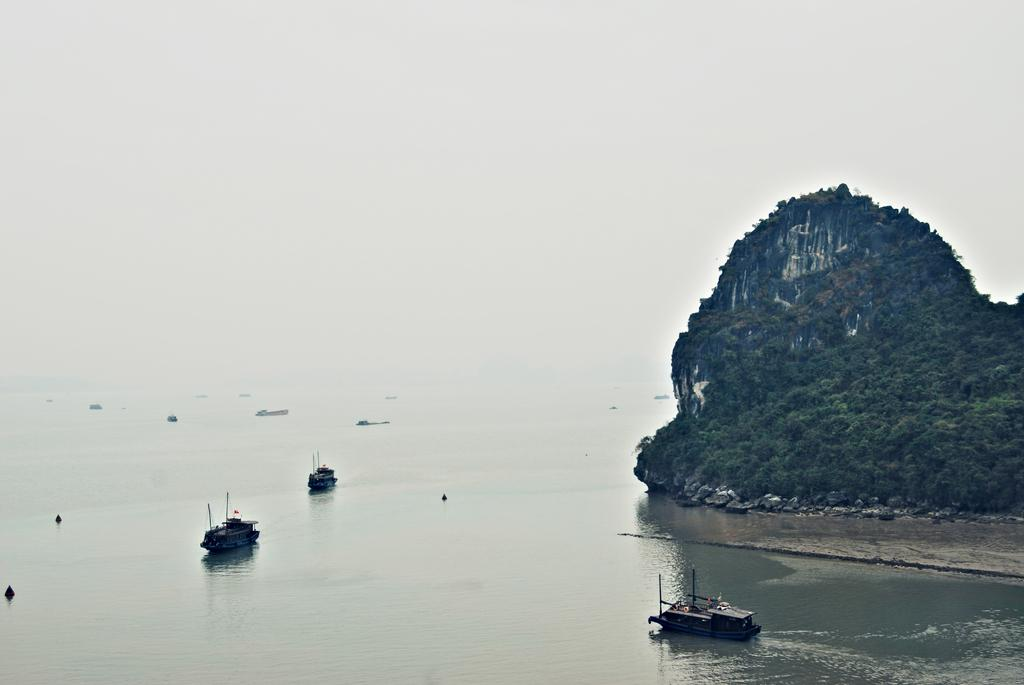What is in the water in the image? There are boats in the water in the image. What can be seen on the right side of the image? There are trees on the right side of the image. What is located behind the trees? There is a hill behind the trees. What is visible behind the hill? The sky is visible behind the hill. What type of cheese is being used to glue the boats together in the image? There is no cheese or glue present in the image; the boats are floating independently in the water. 